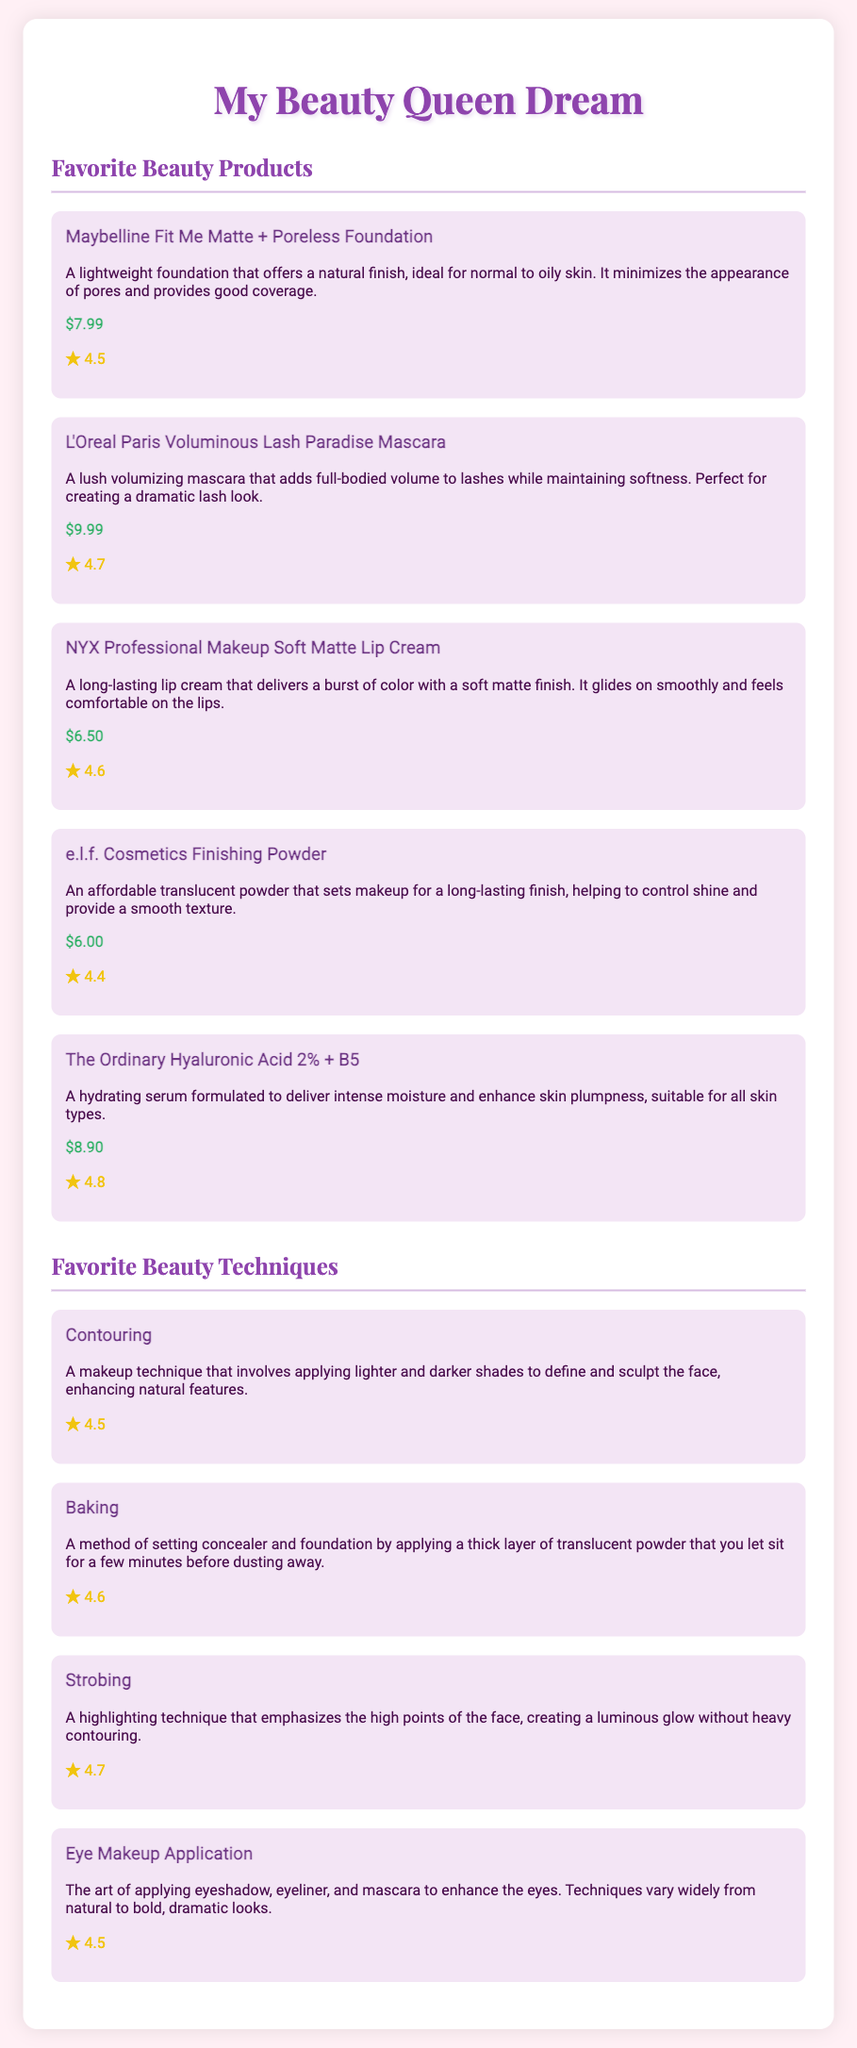What is the price of Maybelline Fit Me Matte + Poreless Foundation? The price of the foundation is listed directly below its description in the document.
Answer: $7.99 What is the rating of L'Oreal Paris Voluminous Lash Paradise Mascara? The rating is displayed next to the product description and indicates its quality based on user feedback.
Answer: 4.7 Which product has the highest rating? The ratings of all products are compared, and the highest one indicates the most preferred item among users.
Answer: The Ordinary Hyaluronic Acid 2% + B5 What beauty technique emphasizes the high points of the face? The technique described focuses on highlighting specific areas to create a natural glow without much contouring.
Answer: Strobing How much does e.l.f. Cosmetics Finishing Powder cost? The cost is mentioned right below the product description in the document.
Answer: $6.00 What is the primary purpose of the baking technique? The technique's purpose is explained within the document as a method to set concealer and foundation effectively.
Answer: To set concealer and foundation What type of foundation is Maybelline Fit Me Matte + Poreless Foundation suitable for? The document describes the intended skin type for the foundation directly in its product description.
Answer: Normal to oily skin Which brand produces the Soft Matte Lip Cream? The brand is explicitly mentioned next to the product name in the document for clarity.
Answer: NYX Professional Makeup 